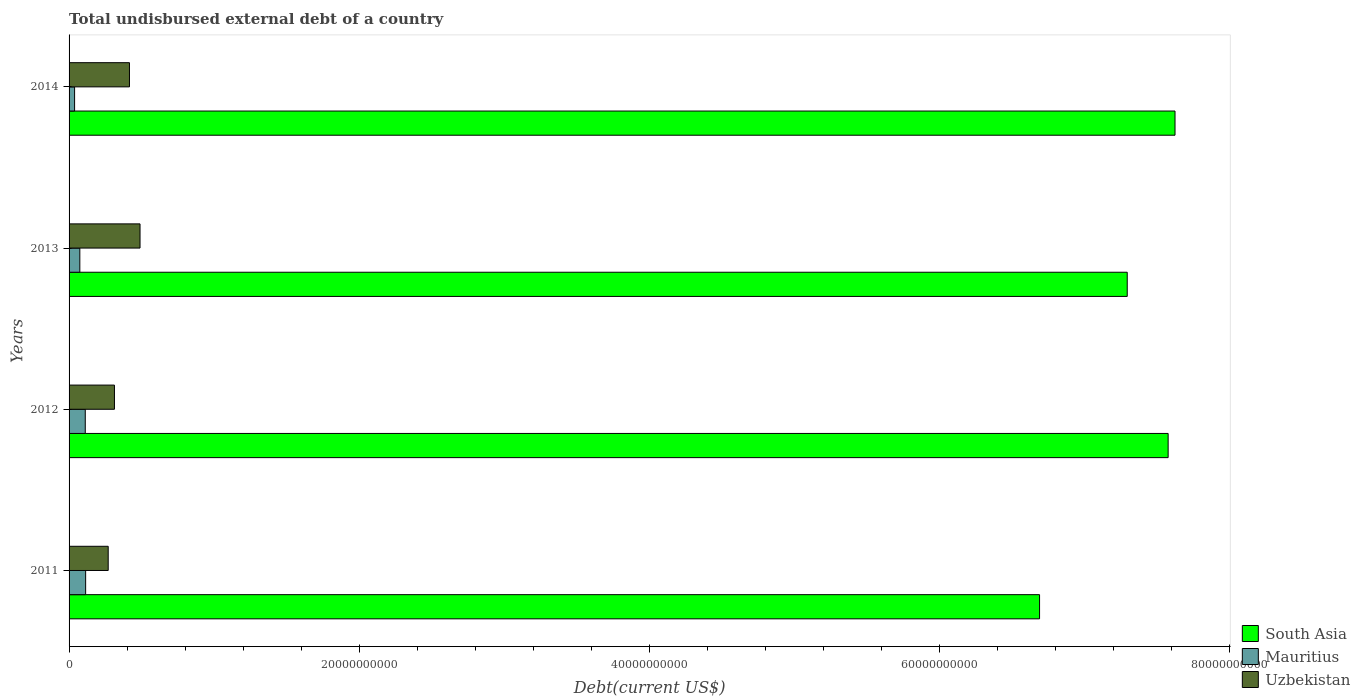How many different coloured bars are there?
Provide a succinct answer. 3. Are the number of bars per tick equal to the number of legend labels?
Keep it short and to the point. Yes. Are the number of bars on each tick of the Y-axis equal?
Offer a very short reply. Yes. What is the total undisbursed external debt in Mauritius in 2011?
Give a very brief answer. 1.14e+09. Across all years, what is the maximum total undisbursed external debt in South Asia?
Offer a terse response. 7.62e+1. Across all years, what is the minimum total undisbursed external debt in South Asia?
Make the answer very short. 6.69e+1. In which year was the total undisbursed external debt in South Asia minimum?
Make the answer very short. 2011. What is the total total undisbursed external debt in South Asia in the graph?
Your response must be concise. 2.92e+11. What is the difference between the total undisbursed external debt in South Asia in 2012 and that in 2013?
Your answer should be compact. 2.82e+09. What is the difference between the total undisbursed external debt in South Asia in 2013 and the total undisbursed external debt in Mauritius in 2012?
Your answer should be very brief. 7.18e+1. What is the average total undisbursed external debt in Mauritius per year?
Your response must be concise. 8.45e+08. In the year 2012, what is the difference between the total undisbursed external debt in Mauritius and total undisbursed external debt in Uzbekistan?
Offer a terse response. -2.01e+09. In how many years, is the total undisbursed external debt in South Asia greater than 28000000000 US$?
Provide a succinct answer. 4. What is the ratio of the total undisbursed external debt in South Asia in 2011 to that in 2014?
Offer a terse response. 0.88. Is the total undisbursed external debt in South Asia in 2011 less than that in 2012?
Your answer should be compact. Yes. Is the difference between the total undisbursed external debt in Mauritius in 2011 and 2012 greater than the difference between the total undisbursed external debt in Uzbekistan in 2011 and 2012?
Keep it short and to the point. Yes. What is the difference between the highest and the second highest total undisbursed external debt in South Asia?
Ensure brevity in your answer.  4.74e+08. What is the difference between the highest and the lowest total undisbursed external debt in Uzbekistan?
Offer a very short reply. 2.19e+09. In how many years, is the total undisbursed external debt in South Asia greater than the average total undisbursed external debt in South Asia taken over all years?
Your answer should be compact. 2. Is the sum of the total undisbursed external debt in Mauritius in 2012 and 2014 greater than the maximum total undisbursed external debt in Uzbekistan across all years?
Your answer should be very brief. No. What does the 2nd bar from the top in 2011 represents?
Provide a short and direct response. Mauritius. What does the 3rd bar from the bottom in 2011 represents?
Keep it short and to the point. Uzbekistan. How many bars are there?
Provide a succinct answer. 12. How many years are there in the graph?
Offer a terse response. 4. What is the difference between two consecutive major ticks on the X-axis?
Your answer should be compact. 2.00e+1. Are the values on the major ticks of X-axis written in scientific E-notation?
Your answer should be compact. No. Does the graph contain any zero values?
Your answer should be very brief. No. Where does the legend appear in the graph?
Keep it short and to the point. Bottom right. How many legend labels are there?
Your response must be concise. 3. What is the title of the graph?
Ensure brevity in your answer.  Total undisbursed external debt of a country. Does "Thailand" appear as one of the legend labels in the graph?
Keep it short and to the point. No. What is the label or title of the X-axis?
Provide a short and direct response. Debt(current US$). What is the Debt(current US$) in South Asia in 2011?
Provide a succinct answer. 6.69e+1. What is the Debt(current US$) in Mauritius in 2011?
Your response must be concise. 1.14e+09. What is the Debt(current US$) in Uzbekistan in 2011?
Make the answer very short. 2.70e+09. What is the Debt(current US$) in South Asia in 2012?
Give a very brief answer. 7.58e+1. What is the Debt(current US$) in Mauritius in 2012?
Give a very brief answer. 1.12e+09. What is the Debt(current US$) of Uzbekistan in 2012?
Your answer should be very brief. 3.13e+09. What is the Debt(current US$) in South Asia in 2013?
Keep it short and to the point. 7.30e+1. What is the Debt(current US$) of Mauritius in 2013?
Offer a terse response. 7.41e+08. What is the Debt(current US$) of Uzbekistan in 2013?
Provide a succinct answer. 4.89e+09. What is the Debt(current US$) in South Asia in 2014?
Ensure brevity in your answer.  7.62e+1. What is the Debt(current US$) in Mauritius in 2014?
Ensure brevity in your answer.  3.81e+08. What is the Debt(current US$) in Uzbekistan in 2014?
Make the answer very short. 4.16e+09. Across all years, what is the maximum Debt(current US$) of South Asia?
Your answer should be compact. 7.62e+1. Across all years, what is the maximum Debt(current US$) of Mauritius?
Keep it short and to the point. 1.14e+09. Across all years, what is the maximum Debt(current US$) in Uzbekistan?
Offer a very short reply. 4.89e+09. Across all years, what is the minimum Debt(current US$) in South Asia?
Offer a very short reply. 6.69e+1. Across all years, what is the minimum Debt(current US$) of Mauritius?
Offer a very short reply. 3.81e+08. Across all years, what is the minimum Debt(current US$) in Uzbekistan?
Offer a terse response. 2.70e+09. What is the total Debt(current US$) in South Asia in the graph?
Provide a succinct answer. 2.92e+11. What is the total Debt(current US$) in Mauritius in the graph?
Provide a short and direct response. 3.38e+09. What is the total Debt(current US$) of Uzbekistan in the graph?
Offer a very short reply. 1.49e+1. What is the difference between the Debt(current US$) in South Asia in 2011 and that in 2012?
Make the answer very short. -8.87e+09. What is the difference between the Debt(current US$) of Mauritius in 2011 and that in 2012?
Your answer should be compact. 2.50e+07. What is the difference between the Debt(current US$) of Uzbekistan in 2011 and that in 2012?
Your response must be concise. -4.31e+08. What is the difference between the Debt(current US$) of South Asia in 2011 and that in 2013?
Your answer should be very brief. -6.04e+09. What is the difference between the Debt(current US$) in Mauritius in 2011 and that in 2013?
Your response must be concise. 4.01e+08. What is the difference between the Debt(current US$) of Uzbekistan in 2011 and that in 2013?
Keep it short and to the point. -2.19e+09. What is the difference between the Debt(current US$) of South Asia in 2011 and that in 2014?
Your answer should be compact. -9.34e+09. What is the difference between the Debt(current US$) in Mauritius in 2011 and that in 2014?
Keep it short and to the point. 7.61e+08. What is the difference between the Debt(current US$) of Uzbekistan in 2011 and that in 2014?
Provide a short and direct response. -1.47e+09. What is the difference between the Debt(current US$) in South Asia in 2012 and that in 2013?
Keep it short and to the point. 2.82e+09. What is the difference between the Debt(current US$) of Mauritius in 2012 and that in 2013?
Offer a terse response. 3.76e+08. What is the difference between the Debt(current US$) of Uzbekistan in 2012 and that in 2013?
Your answer should be very brief. -1.76e+09. What is the difference between the Debt(current US$) in South Asia in 2012 and that in 2014?
Ensure brevity in your answer.  -4.74e+08. What is the difference between the Debt(current US$) of Mauritius in 2012 and that in 2014?
Keep it short and to the point. 7.36e+08. What is the difference between the Debt(current US$) in Uzbekistan in 2012 and that in 2014?
Ensure brevity in your answer.  -1.04e+09. What is the difference between the Debt(current US$) of South Asia in 2013 and that in 2014?
Offer a terse response. -3.29e+09. What is the difference between the Debt(current US$) of Mauritius in 2013 and that in 2014?
Offer a very short reply. 3.60e+08. What is the difference between the Debt(current US$) in Uzbekistan in 2013 and that in 2014?
Your answer should be very brief. 7.28e+08. What is the difference between the Debt(current US$) in South Asia in 2011 and the Debt(current US$) in Mauritius in 2012?
Give a very brief answer. 6.58e+1. What is the difference between the Debt(current US$) in South Asia in 2011 and the Debt(current US$) in Uzbekistan in 2012?
Keep it short and to the point. 6.38e+1. What is the difference between the Debt(current US$) in Mauritius in 2011 and the Debt(current US$) in Uzbekistan in 2012?
Provide a succinct answer. -1.99e+09. What is the difference between the Debt(current US$) in South Asia in 2011 and the Debt(current US$) in Mauritius in 2013?
Make the answer very short. 6.62e+1. What is the difference between the Debt(current US$) of South Asia in 2011 and the Debt(current US$) of Uzbekistan in 2013?
Your answer should be compact. 6.20e+1. What is the difference between the Debt(current US$) of Mauritius in 2011 and the Debt(current US$) of Uzbekistan in 2013?
Your answer should be compact. -3.75e+09. What is the difference between the Debt(current US$) of South Asia in 2011 and the Debt(current US$) of Mauritius in 2014?
Provide a short and direct response. 6.65e+1. What is the difference between the Debt(current US$) in South Asia in 2011 and the Debt(current US$) in Uzbekistan in 2014?
Your response must be concise. 6.27e+1. What is the difference between the Debt(current US$) of Mauritius in 2011 and the Debt(current US$) of Uzbekistan in 2014?
Keep it short and to the point. -3.02e+09. What is the difference between the Debt(current US$) of South Asia in 2012 and the Debt(current US$) of Mauritius in 2013?
Provide a succinct answer. 7.50e+1. What is the difference between the Debt(current US$) in South Asia in 2012 and the Debt(current US$) in Uzbekistan in 2013?
Provide a succinct answer. 7.09e+1. What is the difference between the Debt(current US$) of Mauritius in 2012 and the Debt(current US$) of Uzbekistan in 2013?
Provide a succinct answer. -3.78e+09. What is the difference between the Debt(current US$) of South Asia in 2012 and the Debt(current US$) of Mauritius in 2014?
Give a very brief answer. 7.54e+1. What is the difference between the Debt(current US$) of South Asia in 2012 and the Debt(current US$) of Uzbekistan in 2014?
Provide a short and direct response. 7.16e+1. What is the difference between the Debt(current US$) of Mauritius in 2012 and the Debt(current US$) of Uzbekistan in 2014?
Your answer should be very brief. -3.05e+09. What is the difference between the Debt(current US$) in South Asia in 2013 and the Debt(current US$) in Mauritius in 2014?
Your response must be concise. 7.26e+1. What is the difference between the Debt(current US$) of South Asia in 2013 and the Debt(current US$) of Uzbekistan in 2014?
Provide a succinct answer. 6.88e+1. What is the difference between the Debt(current US$) of Mauritius in 2013 and the Debt(current US$) of Uzbekistan in 2014?
Offer a terse response. -3.42e+09. What is the average Debt(current US$) in South Asia per year?
Ensure brevity in your answer.  7.30e+1. What is the average Debt(current US$) of Mauritius per year?
Give a very brief answer. 8.45e+08. What is the average Debt(current US$) of Uzbekistan per year?
Give a very brief answer. 3.72e+09. In the year 2011, what is the difference between the Debt(current US$) in South Asia and Debt(current US$) in Mauritius?
Your answer should be very brief. 6.58e+1. In the year 2011, what is the difference between the Debt(current US$) in South Asia and Debt(current US$) in Uzbekistan?
Offer a terse response. 6.42e+1. In the year 2011, what is the difference between the Debt(current US$) of Mauritius and Debt(current US$) of Uzbekistan?
Offer a very short reply. -1.56e+09. In the year 2012, what is the difference between the Debt(current US$) in South Asia and Debt(current US$) in Mauritius?
Your answer should be very brief. 7.47e+1. In the year 2012, what is the difference between the Debt(current US$) of South Asia and Debt(current US$) of Uzbekistan?
Provide a short and direct response. 7.26e+1. In the year 2012, what is the difference between the Debt(current US$) of Mauritius and Debt(current US$) of Uzbekistan?
Provide a succinct answer. -2.01e+09. In the year 2013, what is the difference between the Debt(current US$) of South Asia and Debt(current US$) of Mauritius?
Offer a terse response. 7.22e+1. In the year 2013, what is the difference between the Debt(current US$) of South Asia and Debt(current US$) of Uzbekistan?
Your answer should be very brief. 6.81e+1. In the year 2013, what is the difference between the Debt(current US$) in Mauritius and Debt(current US$) in Uzbekistan?
Ensure brevity in your answer.  -4.15e+09. In the year 2014, what is the difference between the Debt(current US$) of South Asia and Debt(current US$) of Mauritius?
Keep it short and to the point. 7.59e+1. In the year 2014, what is the difference between the Debt(current US$) of South Asia and Debt(current US$) of Uzbekistan?
Offer a very short reply. 7.21e+1. In the year 2014, what is the difference between the Debt(current US$) in Mauritius and Debt(current US$) in Uzbekistan?
Your answer should be very brief. -3.78e+09. What is the ratio of the Debt(current US$) of South Asia in 2011 to that in 2012?
Your answer should be very brief. 0.88. What is the ratio of the Debt(current US$) in Mauritius in 2011 to that in 2012?
Your answer should be compact. 1.02. What is the ratio of the Debt(current US$) in Uzbekistan in 2011 to that in 2012?
Your response must be concise. 0.86. What is the ratio of the Debt(current US$) of South Asia in 2011 to that in 2013?
Keep it short and to the point. 0.92. What is the ratio of the Debt(current US$) of Mauritius in 2011 to that in 2013?
Your answer should be compact. 1.54. What is the ratio of the Debt(current US$) in Uzbekistan in 2011 to that in 2013?
Provide a short and direct response. 0.55. What is the ratio of the Debt(current US$) in South Asia in 2011 to that in 2014?
Ensure brevity in your answer.  0.88. What is the ratio of the Debt(current US$) of Mauritius in 2011 to that in 2014?
Your answer should be very brief. 3. What is the ratio of the Debt(current US$) of Uzbekistan in 2011 to that in 2014?
Offer a very short reply. 0.65. What is the ratio of the Debt(current US$) in South Asia in 2012 to that in 2013?
Make the answer very short. 1.04. What is the ratio of the Debt(current US$) of Mauritius in 2012 to that in 2013?
Offer a terse response. 1.51. What is the ratio of the Debt(current US$) in Uzbekistan in 2012 to that in 2013?
Ensure brevity in your answer.  0.64. What is the ratio of the Debt(current US$) in South Asia in 2012 to that in 2014?
Your answer should be compact. 0.99. What is the ratio of the Debt(current US$) of Mauritius in 2012 to that in 2014?
Your answer should be compact. 2.93. What is the ratio of the Debt(current US$) of Uzbekistan in 2012 to that in 2014?
Provide a succinct answer. 0.75. What is the ratio of the Debt(current US$) in South Asia in 2013 to that in 2014?
Your answer should be very brief. 0.96. What is the ratio of the Debt(current US$) in Mauritius in 2013 to that in 2014?
Your answer should be very brief. 1.94. What is the ratio of the Debt(current US$) in Uzbekistan in 2013 to that in 2014?
Offer a terse response. 1.17. What is the difference between the highest and the second highest Debt(current US$) of South Asia?
Offer a terse response. 4.74e+08. What is the difference between the highest and the second highest Debt(current US$) of Mauritius?
Provide a short and direct response. 2.50e+07. What is the difference between the highest and the second highest Debt(current US$) of Uzbekistan?
Make the answer very short. 7.28e+08. What is the difference between the highest and the lowest Debt(current US$) of South Asia?
Offer a very short reply. 9.34e+09. What is the difference between the highest and the lowest Debt(current US$) of Mauritius?
Make the answer very short. 7.61e+08. What is the difference between the highest and the lowest Debt(current US$) of Uzbekistan?
Your response must be concise. 2.19e+09. 